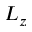<formula> <loc_0><loc_0><loc_500><loc_500>L _ { z }</formula> 